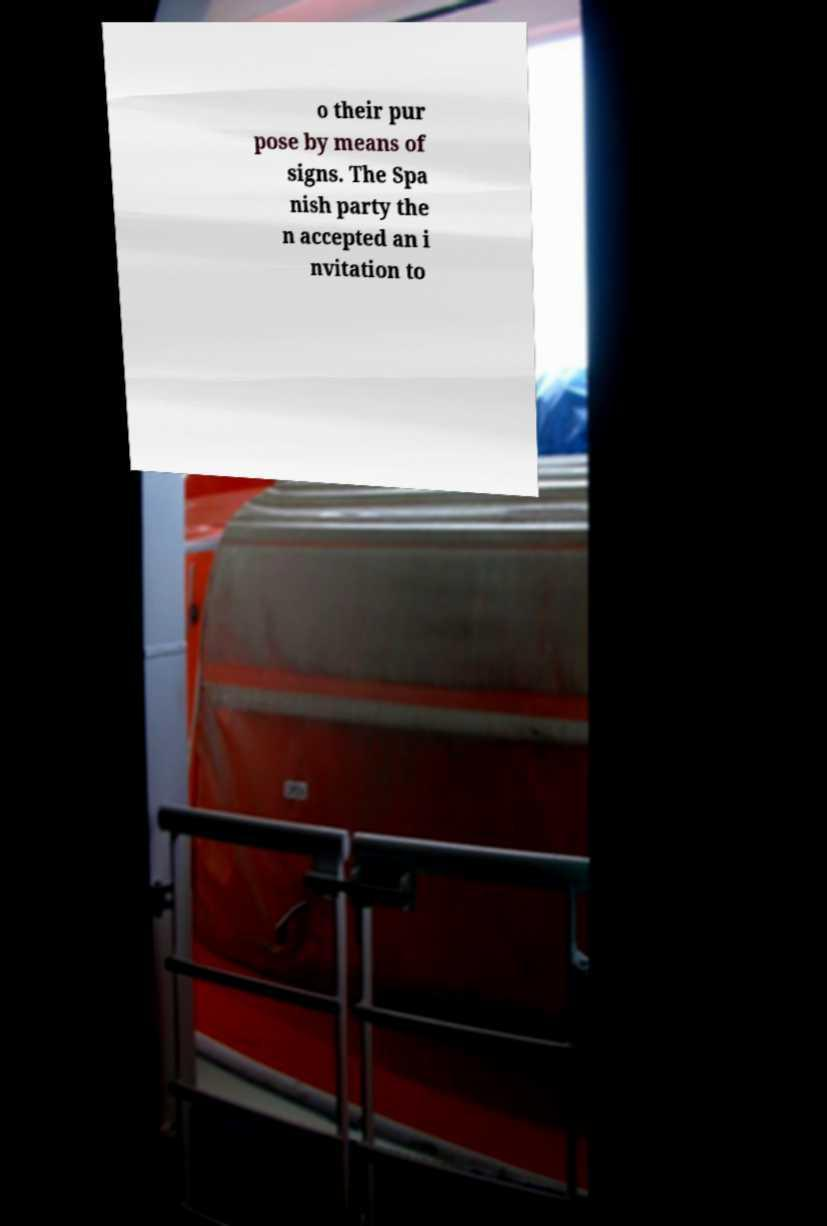Please identify and transcribe the text found in this image. o their pur pose by means of signs. The Spa nish party the n accepted an i nvitation to 